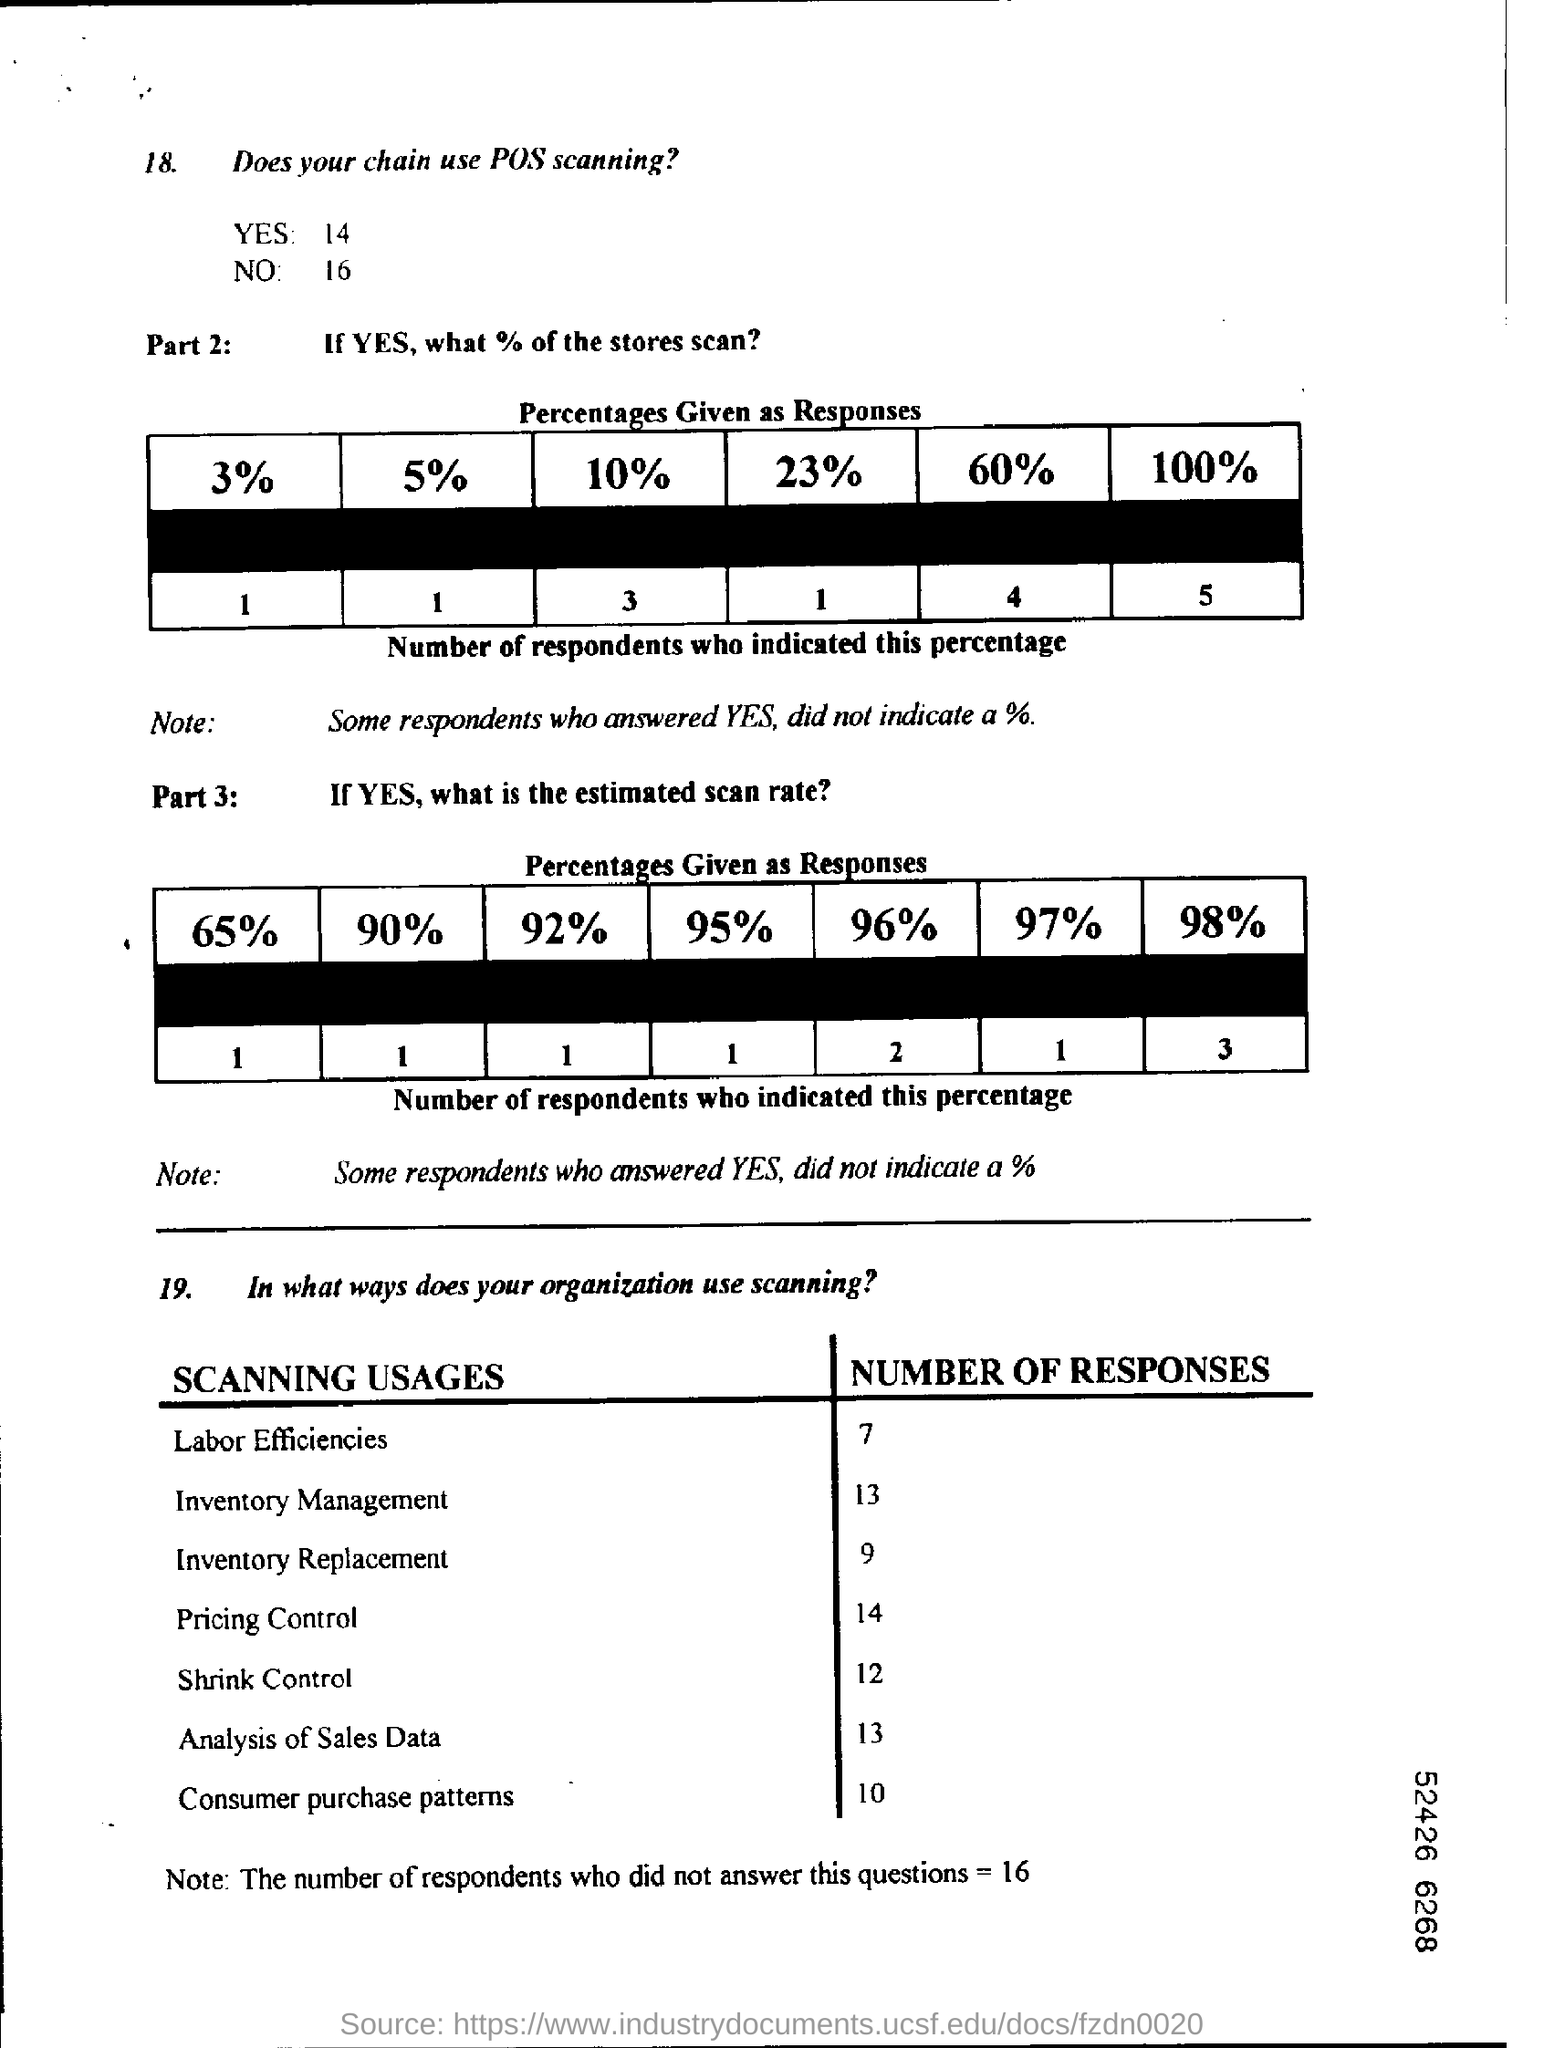Indicate a few pertinent items in this graphic. The inventory management survey received 13 responses. The number of responses to the pricing control survey is 14. The inventory replacement process has received 9 responses. In the Labor Efficiencies section, there were 7 responses. 